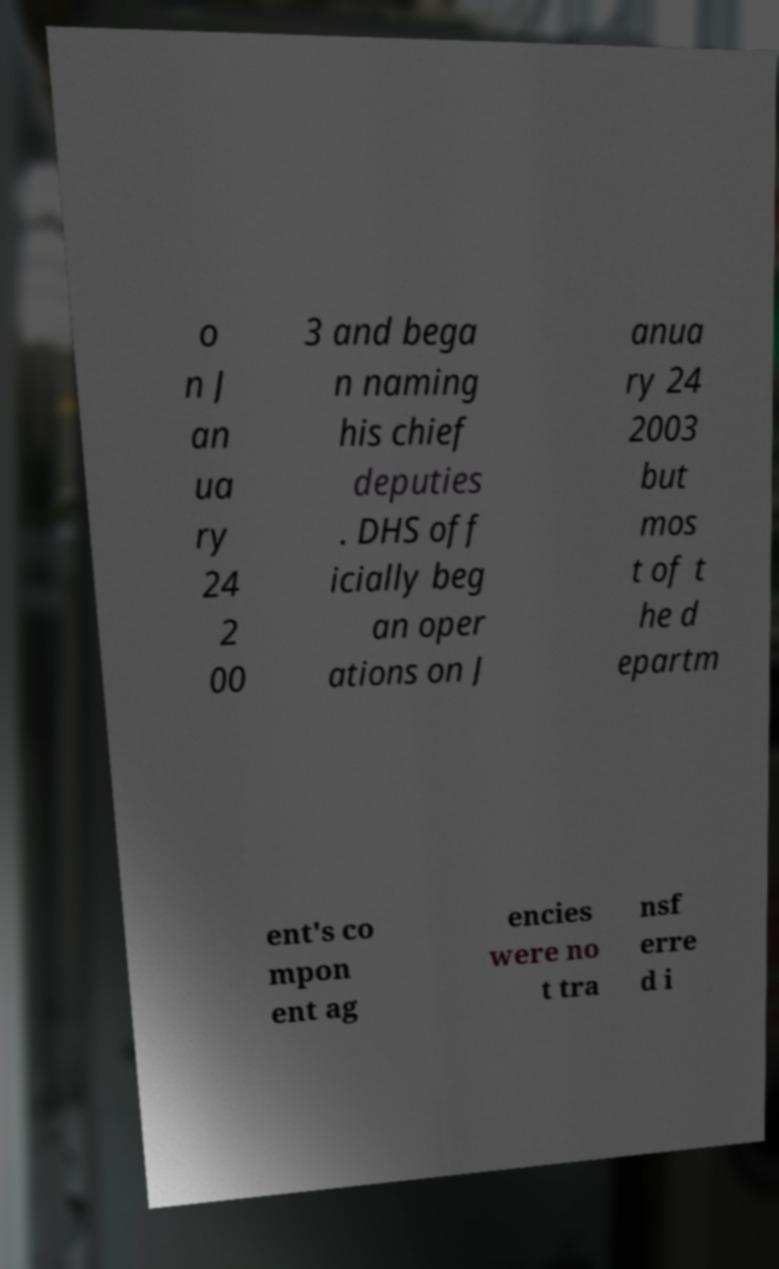There's text embedded in this image that I need extracted. Can you transcribe it verbatim? o n J an ua ry 24 2 00 3 and bega n naming his chief deputies . DHS off icially beg an oper ations on J anua ry 24 2003 but mos t of t he d epartm ent's co mpon ent ag encies were no t tra nsf erre d i 